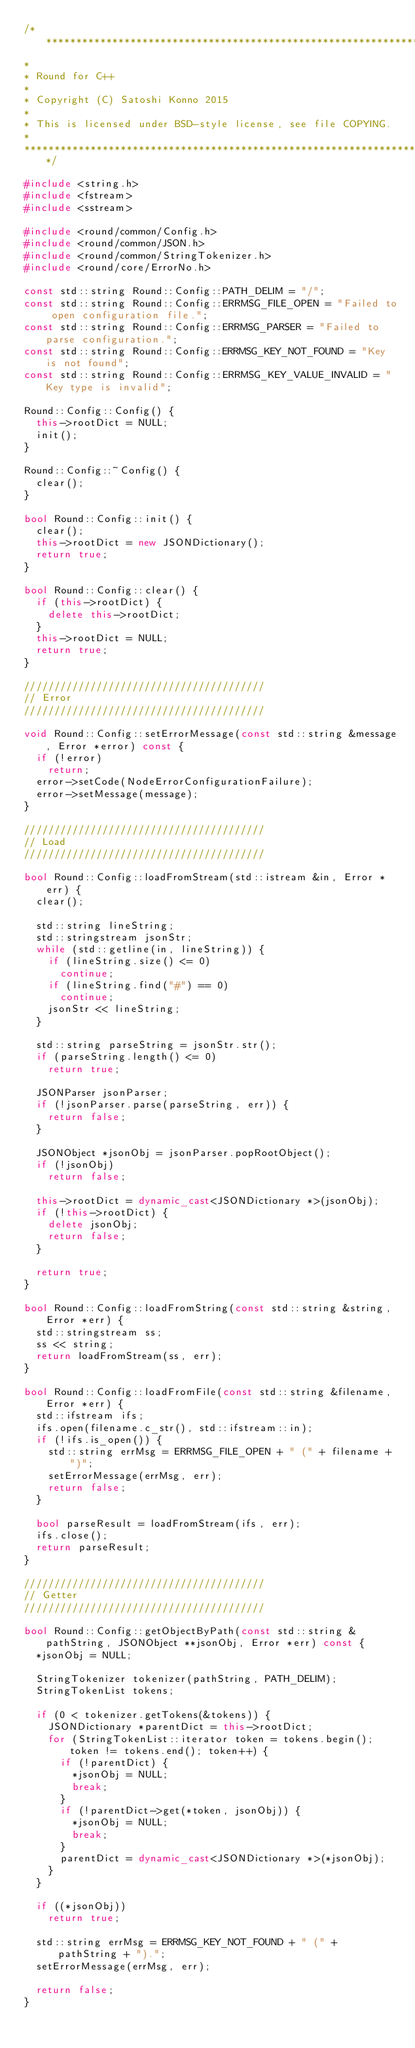Convert code to text. <code><loc_0><loc_0><loc_500><loc_500><_C++_>/******************************************************************
*
* Round for C++
*
* Copyright (C) Satoshi Konno 2015
*
* This is licensed under BSD-style license, see file COPYING.
*
******************************************************************/

#include <string.h>
#include <fstream>
#include <sstream>

#include <round/common/Config.h>
#include <round/common/JSON.h>
#include <round/common/StringTokenizer.h>
#include <round/core/ErrorNo.h>

const std::string Round::Config::PATH_DELIM = "/";
const std::string Round::Config::ERRMSG_FILE_OPEN = "Failed to open configuration file.";
const std::string Round::Config::ERRMSG_PARSER = "Failed to parse configuration.";
const std::string Round::Config::ERRMSG_KEY_NOT_FOUND = "Key is not found";
const std::string Round::Config::ERRMSG_KEY_VALUE_INVALID = "Key type is invalid";

Round::Config::Config() {
  this->rootDict = NULL;
  init();
}

Round::Config::~Config() {
  clear();
}

bool Round::Config::init() {
  clear();
  this->rootDict = new JSONDictionary();
  return true;
}

bool Round::Config::clear() {
  if (this->rootDict) {
    delete this->rootDict;
  }
  this->rootDict = NULL;
  return true;
}

////////////////////////////////////////
// Error
////////////////////////////////////////

void Round::Config::setErrorMessage(const std::string &message, Error *error) const {
  if (!error)
    return;
  error->setCode(NodeErrorConfigurationFailure);
  error->setMessage(message);
}

////////////////////////////////////////
// Load
////////////////////////////////////////

bool Round::Config::loadFromStream(std::istream &in, Error *err) {
  clear();
  
  std::string lineString;
  std::stringstream jsonStr;
  while (std::getline(in, lineString)) {
    if (lineString.size() <= 0)
      continue;
    if (lineString.find("#") == 0)
      continue;
    jsonStr << lineString;
  }

  std::string parseString = jsonStr.str();
  if (parseString.length() <= 0)
    return true;
  
  JSONParser jsonParser;
  if (!jsonParser.parse(parseString, err)) {
    return false;
  }
      
  JSONObject *jsonObj = jsonParser.popRootObject();
  if (!jsonObj)
    return false;

  this->rootDict = dynamic_cast<JSONDictionary *>(jsonObj);
  if (!this->rootDict) {
    delete jsonObj;
    return false;
  }

  return true;
}

bool Round::Config::loadFromString(const std::string &string, Error *err) {
  std::stringstream ss;
  ss << string;
  return loadFromStream(ss, err);
}

bool Round::Config::loadFromFile(const std::string &filename, Error *err) {
  std::ifstream ifs;
  ifs.open(filename.c_str(), std::ifstream::in); 
  if (!ifs.is_open()) {
    std::string errMsg = ERRMSG_FILE_OPEN + " (" + filename + ")";
    setErrorMessage(errMsg, err);
    return false;
  }
  
  bool parseResult = loadFromStream(ifs, err);
  ifs.close();
  return parseResult; 
}

////////////////////////////////////////
// Getter
////////////////////////////////////////

bool Round::Config::getObjectByPath(const std::string &pathString, JSONObject **jsonObj, Error *err) const {
  *jsonObj = NULL;
  
  StringTokenizer tokenizer(pathString, PATH_DELIM);
  StringTokenList tokens;

  if (0 < tokenizer.getTokens(&tokens)) {
    JSONDictionary *parentDict = this->rootDict;
    for (StringTokenList::iterator token = tokens.begin(); token != tokens.end(); token++) {
      if (!parentDict) {
        *jsonObj = NULL;
        break;
      }
      if (!parentDict->get(*token, jsonObj)) {
        *jsonObj = NULL;
        break;
      }
      parentDict = dynamic_cast<JSONDictionary *>(*jsonObj);
    }
  }

  if ((*jsonObj))
    return true;
  
  std::string errMsg = ERRMSG_KEY_NOT_FOUND + " (" + pathString + ").";
  setErrorMessage(errMsg, err);
  
  return false;
}
</code> 